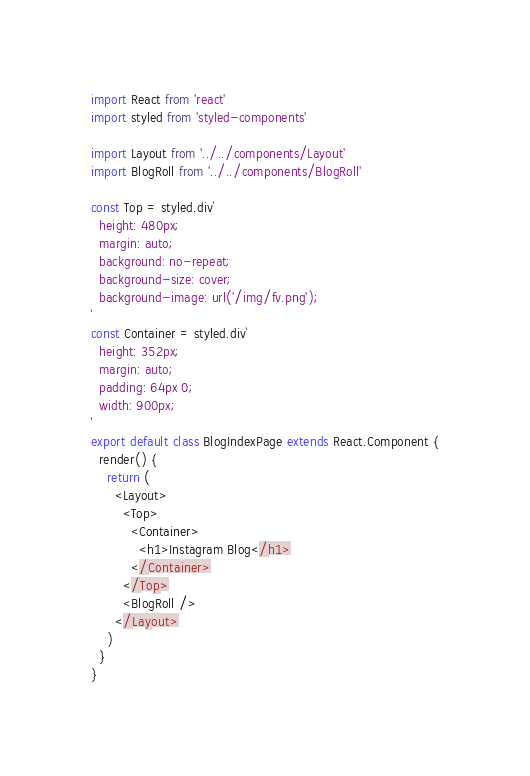Convert code to text. <code><loc_0><loc_0><loc_500><loc_500><_JavaScript_>import React from 'react'
import styled from 'styled-components'

import Layout from '../../components/Layout'
import BlogRoll from '../../components/BlogRoll'

const Top = styled.div`
  height: 480px;
  margin: auto;
  background: no-repeat;
  background-size: cover;
  background-image: url('/img/fv.png');
`
const Container = styled.div`
  height: 352px;
  margin: auto;
  padding: 64px 0;
  width: 900px;
`
export default class BlogIndexPage extends React.Component {
  render() {
    return (
      <Layout>
        <Top>
          <Container>
            <h1>Instagram Blog</h1>
          </Container>
        </Top>
        <BlogRoll />
      </Layout>
    )
  }
}
</code> 